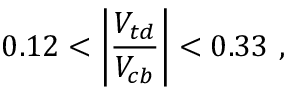Convert formula to latex. <formula><loc_0><loc_0><loc_500><loc_500>0 . 1 2 < \left | \frac { V _ { t d } } { V _ { c b } } \right | < 0 . 3 3 ,</formula> 